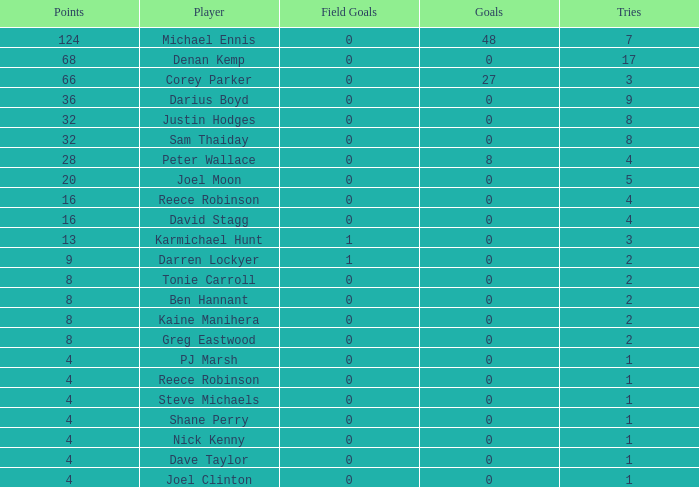What is the total number of field goals of Denan Kemp, who has more than 4 tries, more than 32 points, and 0 goals? 1.0. 